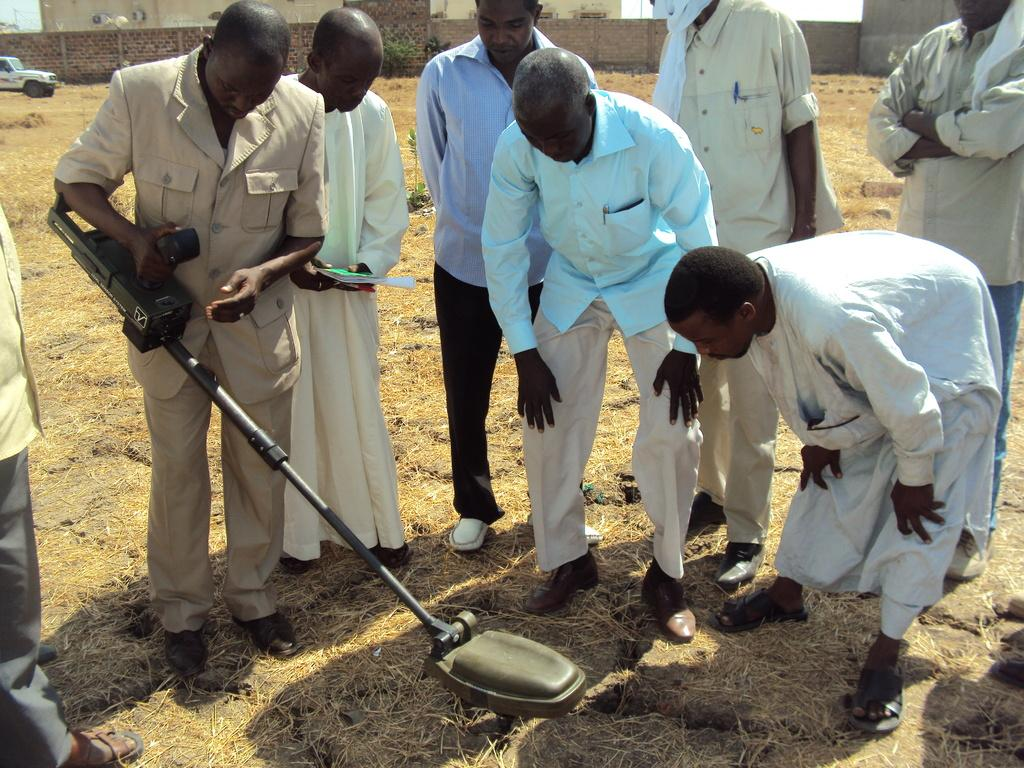What is the main subject in the center of the image? There is a crew in the center of the image. What can be seen in the top left side of the image? There is a car in the top left side of the image. What type of structures are visible at the top side of the image? There are buildings at the top side of the image. How many rabbits are talking to each other in the image? There are no rabbits present in the image, and therefore no such conversation can be observed. 